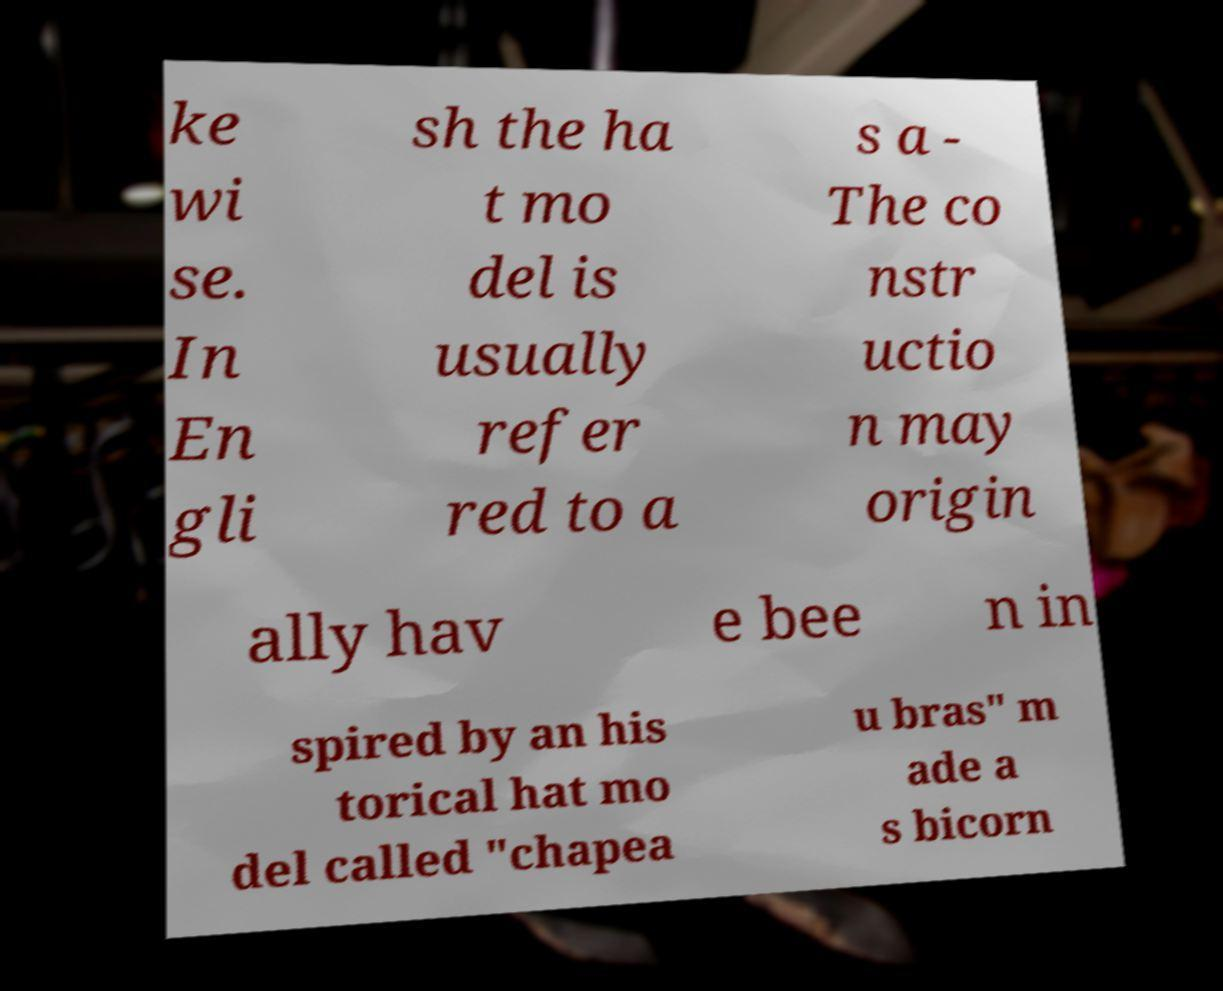Could you assist in decoding the text presented in this image and type it out clearly? ke wi se. In En gli sh the ha t mo del is usually refer red to a s a - The co nstr uctio n may origin ally hav e bee n in spired by an his torical hat mo del called "chapea u bras" m ade a s bicorn 